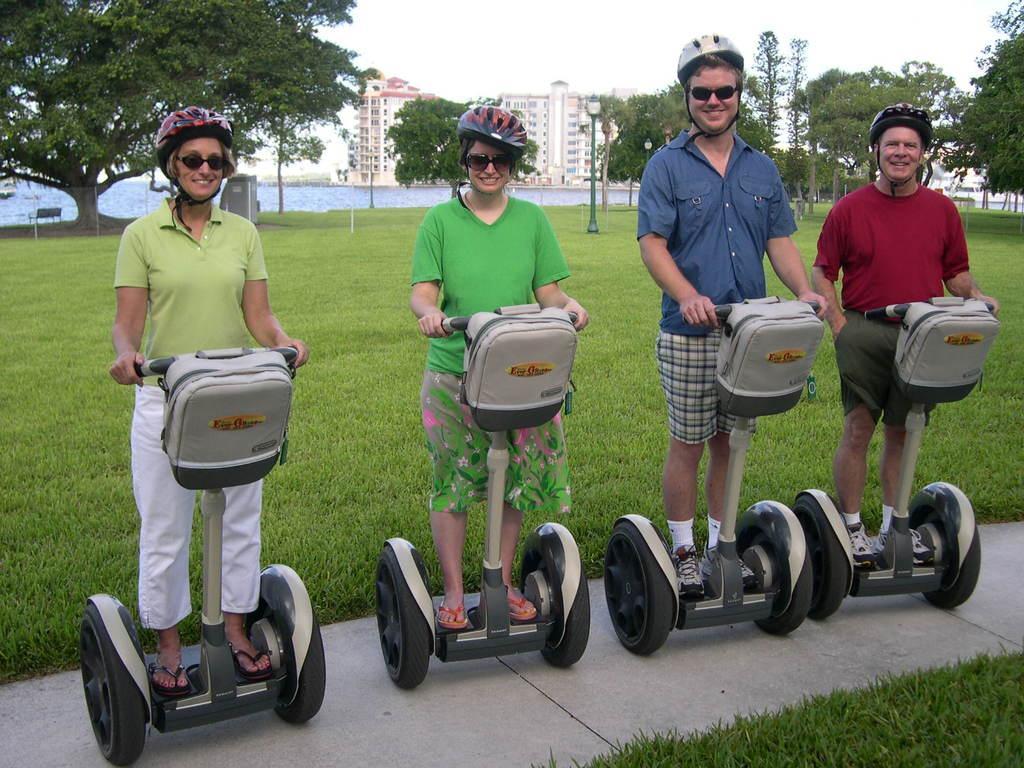Please provide a concise description of this image. In this image I can see four people on the segway. I can see the grass and the pole. On the left side I can see a bench. In the background, I can see the trees, buildings and the sky. 